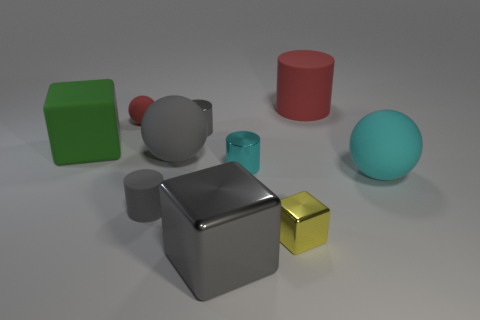There is a large object that is the same color as the small ball; what shape is it?
Your response must be concise. Cylinder. What material is the red thing that is to the right of the red matte ball?
Make the answer very short. Rubber. What number of objects are either purple metallic cylinders or shiny cylinders behind the green matte thing?
Offer a very short reply. 1. What is the shape of the gray metal thing that is the same size as the cyan metallic cylinder?
Provide a succinct answer. Cylinder. What number of rubber blocks are the same color as the tiny metallic block?
Keep it short and to the point. 0. Is the material of the gray cylinder that is in front of the cyan cylinder the same as the gray block?
Ensure brevity in your answer.  No. What is the shape of the tiny red object?
Give a very brief answer. Sphere. What number of yellow things are big blocks or big cylinders?
Give a very brief answer. 0. What number of other things are there of the same material as the small cube
Keep it short and to the point. 3. Does the tiny shiny object on the left side of the cyan metal cylinder have the same shape as the tiny cyan shiny thing?
Keep it short and to the point. Yes. 